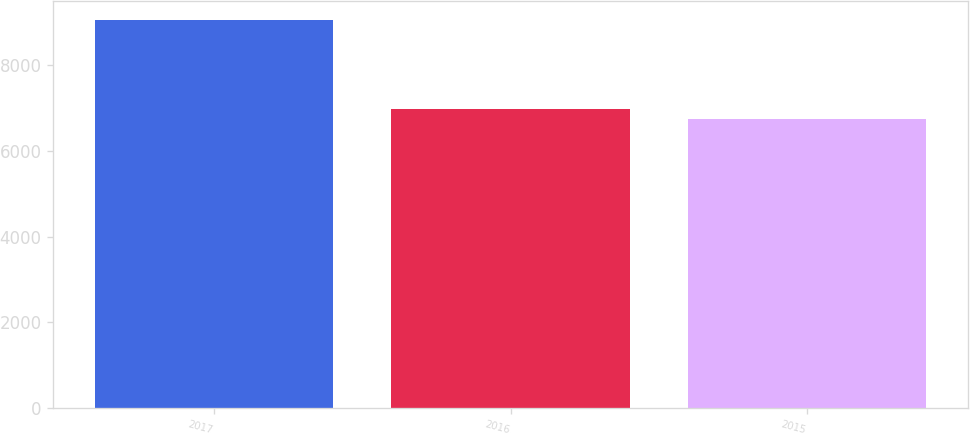<chart> <loc_0><loc_0><loc_500><loc_500><bar_chart><fcel>2017<fcel>2016<fcel>2015<nl><fcel>9059<fcel>6971<fcel>6739<nl></chart> 